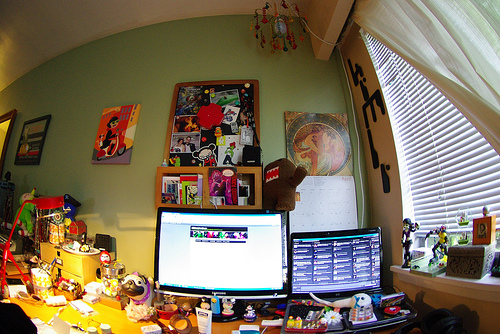<image>
Can you confirm if the dog is to the left of the computer? Yes. From this viewpoint, the dog is positioned to the left side relative to the computer. 